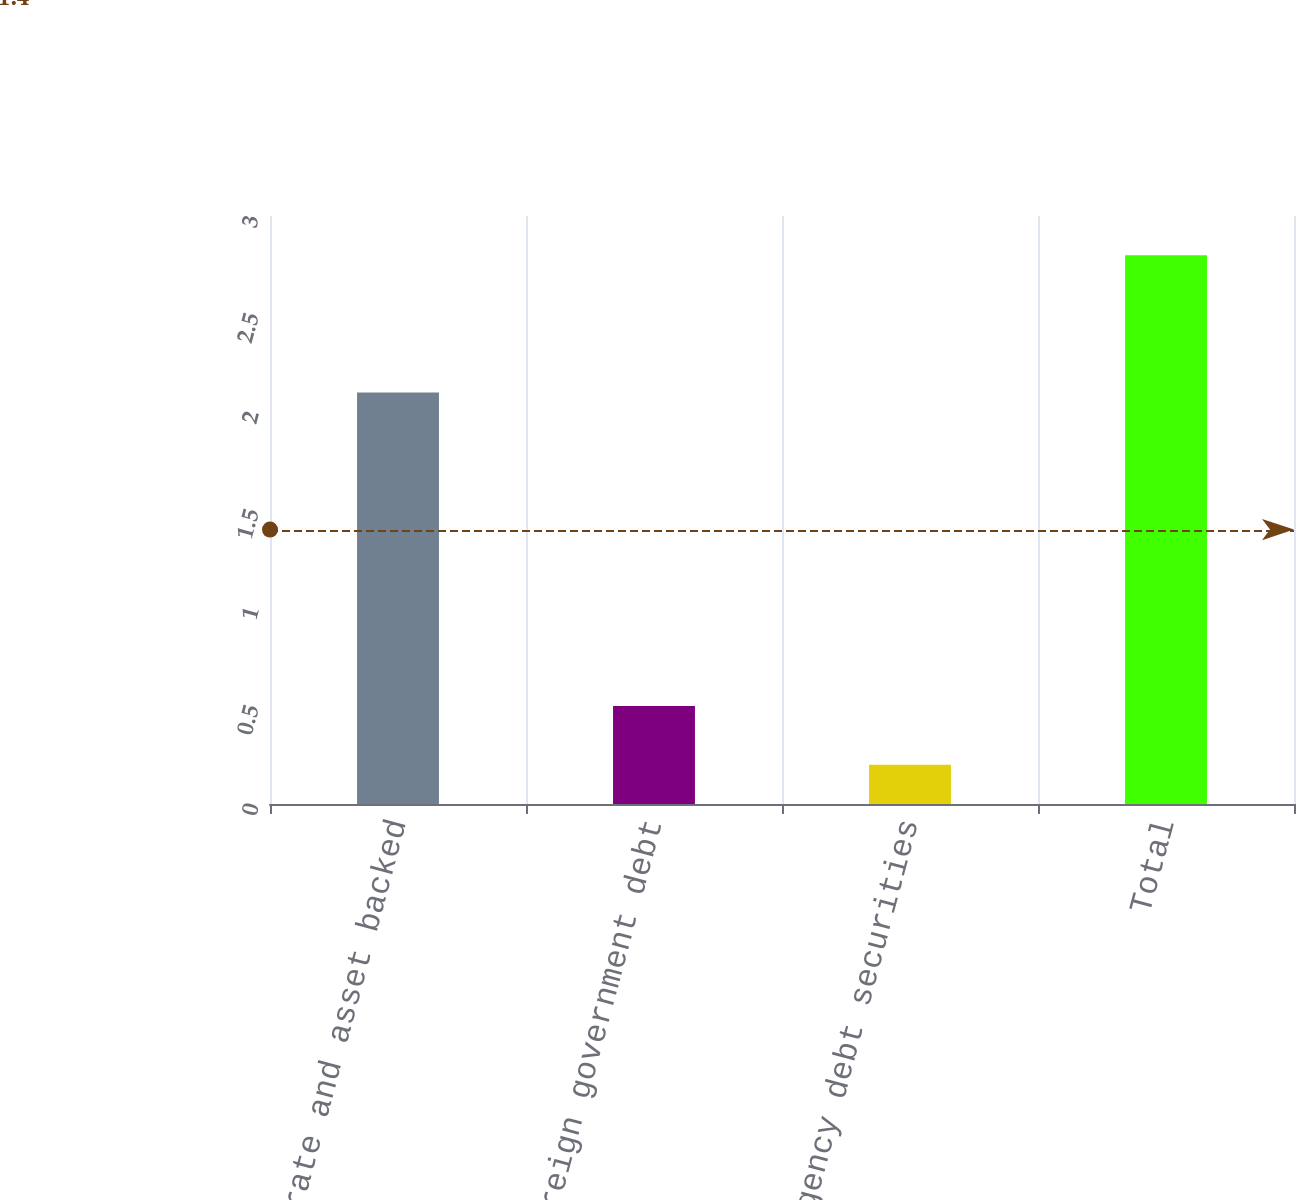<chart> <loc_0><loc_0><loc_500><loc_500><bar_chart><fcel>Corporate and asset backed<fcel>Foreign government debt<fcel>US agency debt securities<fcel>Total<nl><fcel>2.1<fcel>0.5<fcel>0.2<fcel>2.8<nl></chart> 